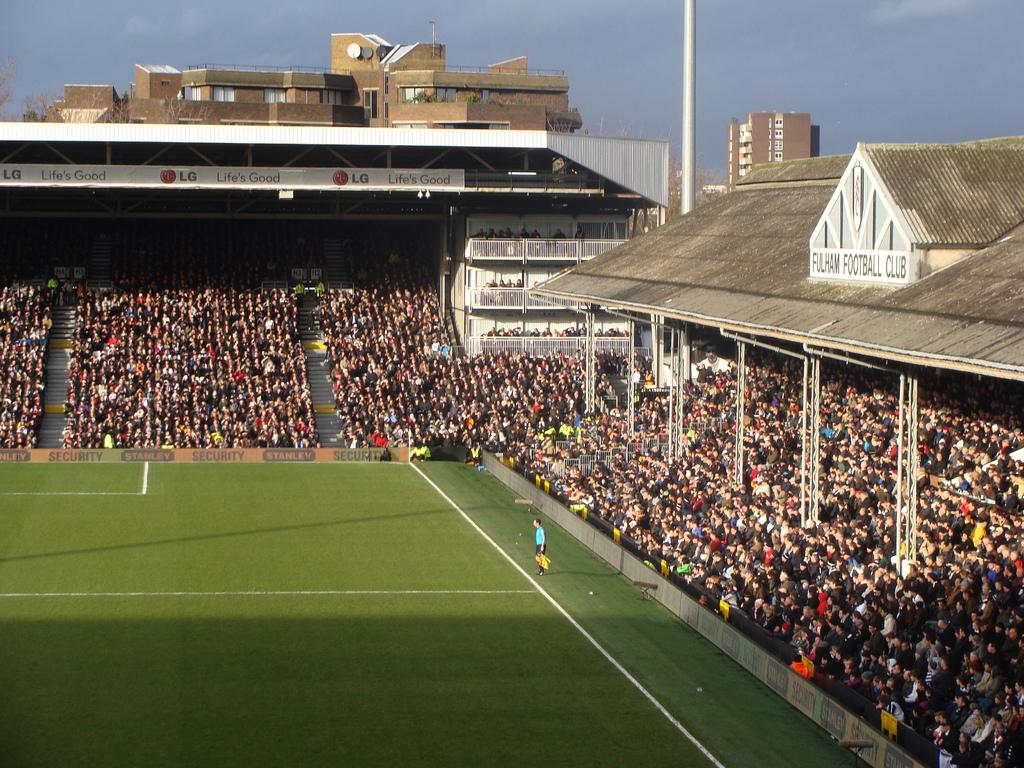How many people are in the image? There is a group of people in the image. What are the people in the image doing? Some people are standing, while others are seated. What can be seen in the background of the image? There are buildings and a pole in the background of the image. What type of surface is visible in the image? Grass is present in the image. Can you see a curtain in the image? There is no curtain present in the image. Are there any boys in the image? The provided facts do not mention the gender of the people in the image, so it cannot be determined if there are any boys present. 